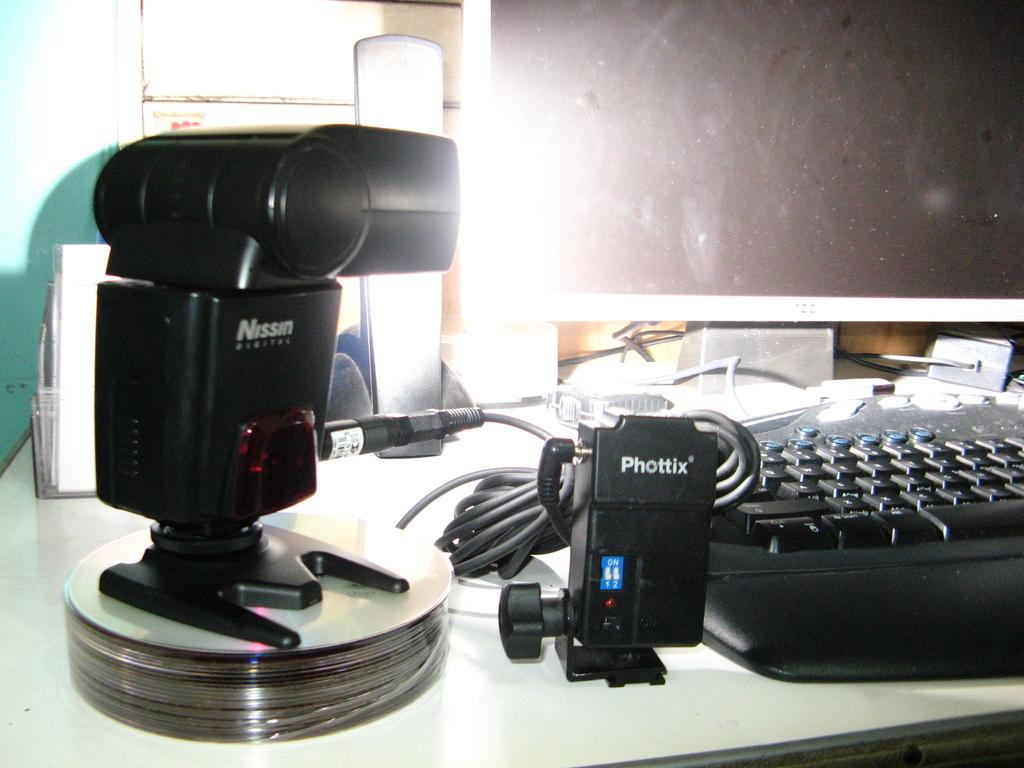<image>
Create a compact narrative representing the image presented. A Nissin camera or camera lens sits on top of some CD's next to an electronic labeled Phottix. 